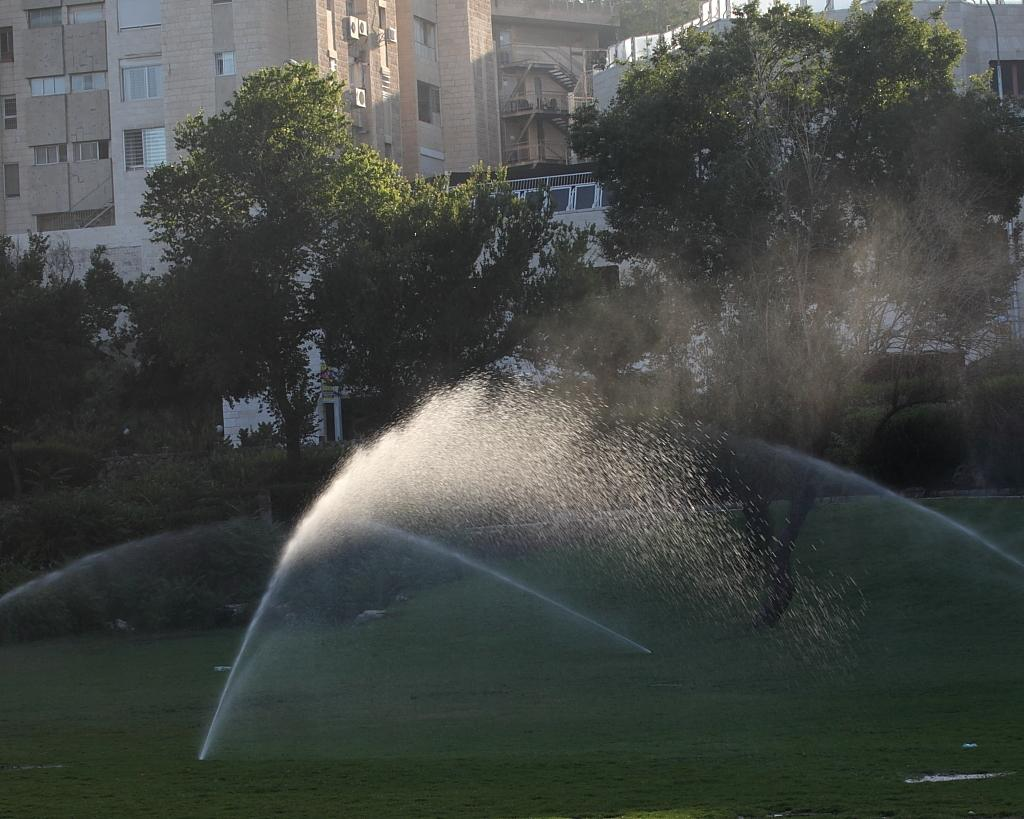What type of setting is depicted in the image? The image appears to depict a garden. What type of vegetation is present at the bottom of the image? There is grass at the bottom of the image. What type of man-made structures are visible at the bottom of the image? There are water pipes visible at the bottom of the image. What type of natural elements can be seen in the background of the image? There are trees in the background of the image. What type of human-made structures can be seen in the background of the image? There are buildings in the background of the image. Where is the grandfather sitting in the image? There is no grandfather present in the image. What type of clothing is the coat hanging on the tub in the image? There is no tub or coat present in the image. 